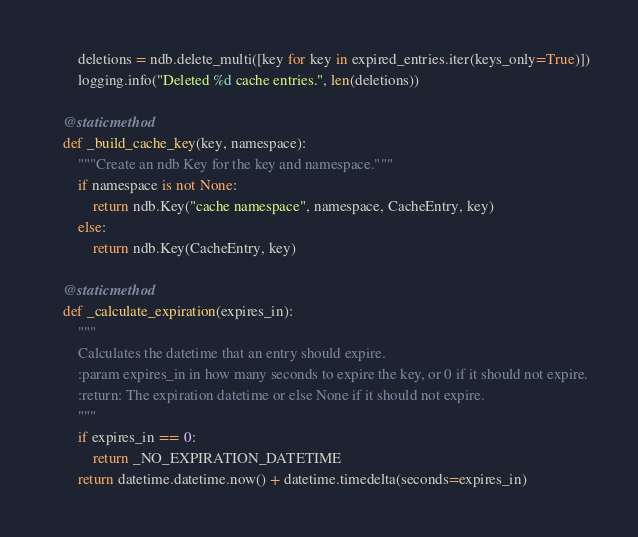<code> <loc_0><loc_0><loc_500><loc_500><_Python_>        deletions = ndb.delete_multi([key for key in expired_entries.iter(keys_only=True)])
        logging.info("Deleted %d cache entries.", len(deletions))

    @staticmethod
    def _build_cache_key(key, namespace):
        """Create an ndb Key for the key and namespace."""
        if namespace is not None:
            return ndb.Key("cache namespace", namespace, CacheEntry, key)
        else:
            return ndb.Key(CacheEntry, key)

    @staticmethod
    def _calculate_expiration(expires_in):
        """
        Calculates the datetime that an entry should expire.
        :param expires_in in how many seconds to expire the key, or 0 if it should not expire.
        :return: The expiration datetime or else None if it should not expire.
        """
        if expires_in == 0:
            return _NO_EXPIRATION_DATETIME
        return datetime.datetime.now() + datetime.timedelta(seconds=expires_in)
</code> 